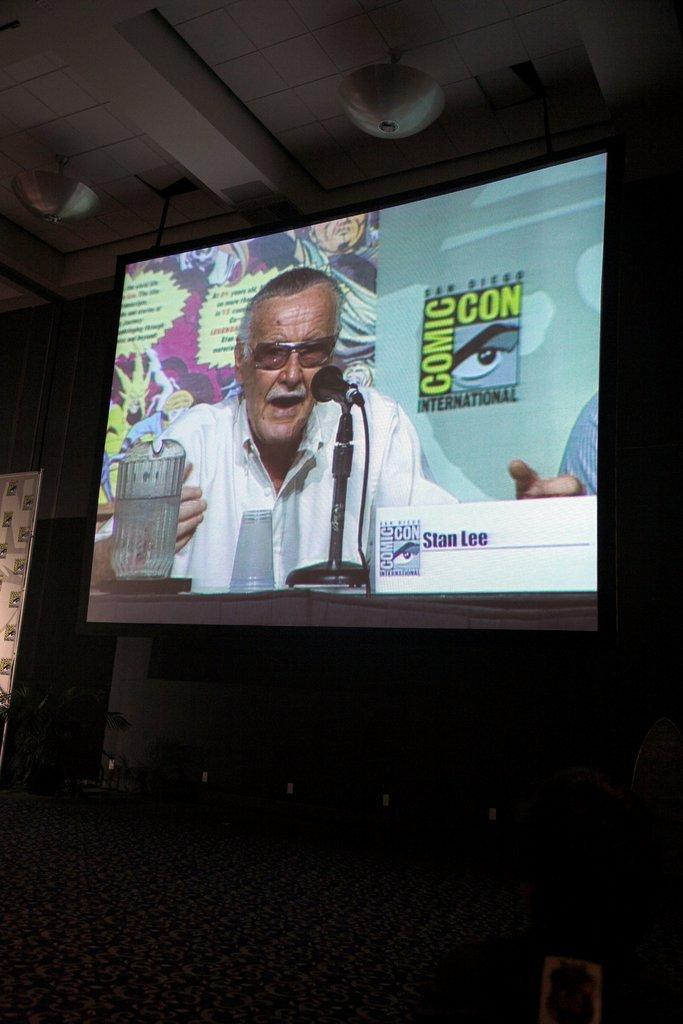<image>
Share a concise interpretation of the image provided. A man is speakng at comic con displayed on the screen. 